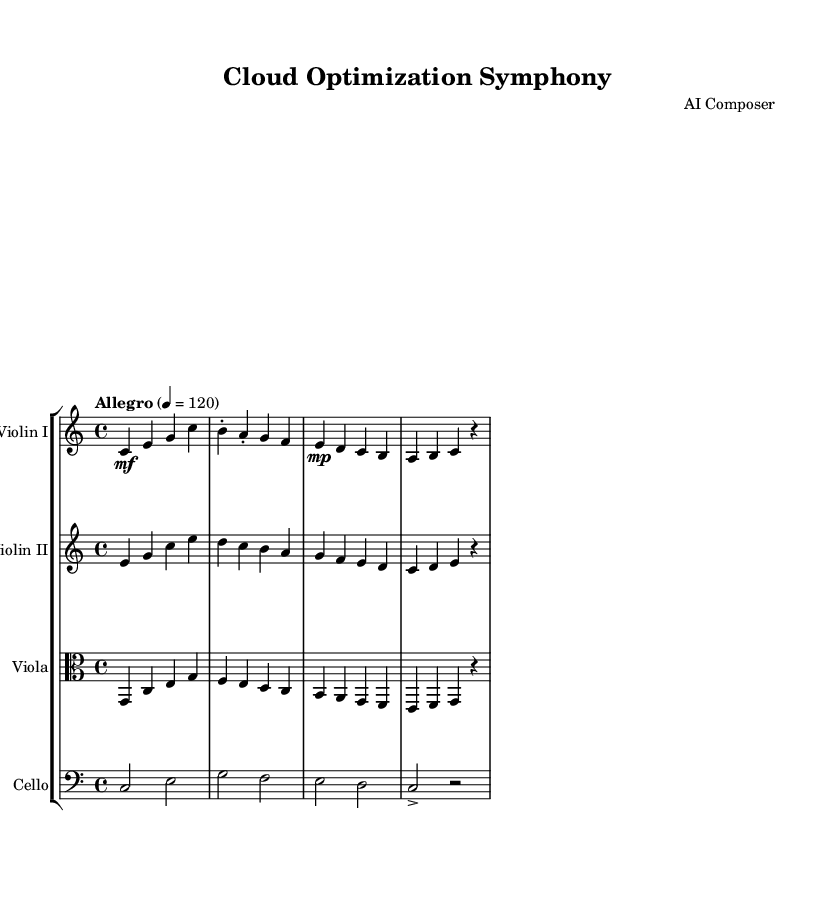What is the key signature of this music? The key signature is indicated by the absence of sharps or flats, which means it is in the key of C major.
Answer: C major What is the time signature of this music? The time signature is found at the beginning of the staff, indicating the structure of the music in measures divisible by four. This is typically shown as a fraction as 4 over 4.
Answer: 4/4 What is the tempo marking of this composition? The tempo marking is shown in Italian terms and provides the speed at which the piece should be played. It appears as "Allegro" with a tempo of 120 beats per minute.
Answer: Allegro How many instruments are featured in this symphony? The score indicates a Staff Group containing four distinct staffs, each representing a different instrument within a string orchestra.
Answer: Four Which instrument has the highest pitch range in this symphony? The highest pitch is typically sounded by the first violin, which plays the highest notes compared to the other instruments within the composition.
Answer: Violin I What dynamic marking is used at the beginning of the first violin part? The dynamic marking at the start of the first violin indicates a moderate volume, represented by the term 'mf,' which stands for mezzo-forte.
Answer: mf What is the rest duration in the last measure of the cello part? The last measure of the cello part contains a rest symbol followed by a duration, indicating a pause in sound is taken for the length of that measure.
Answer: Whole rest 